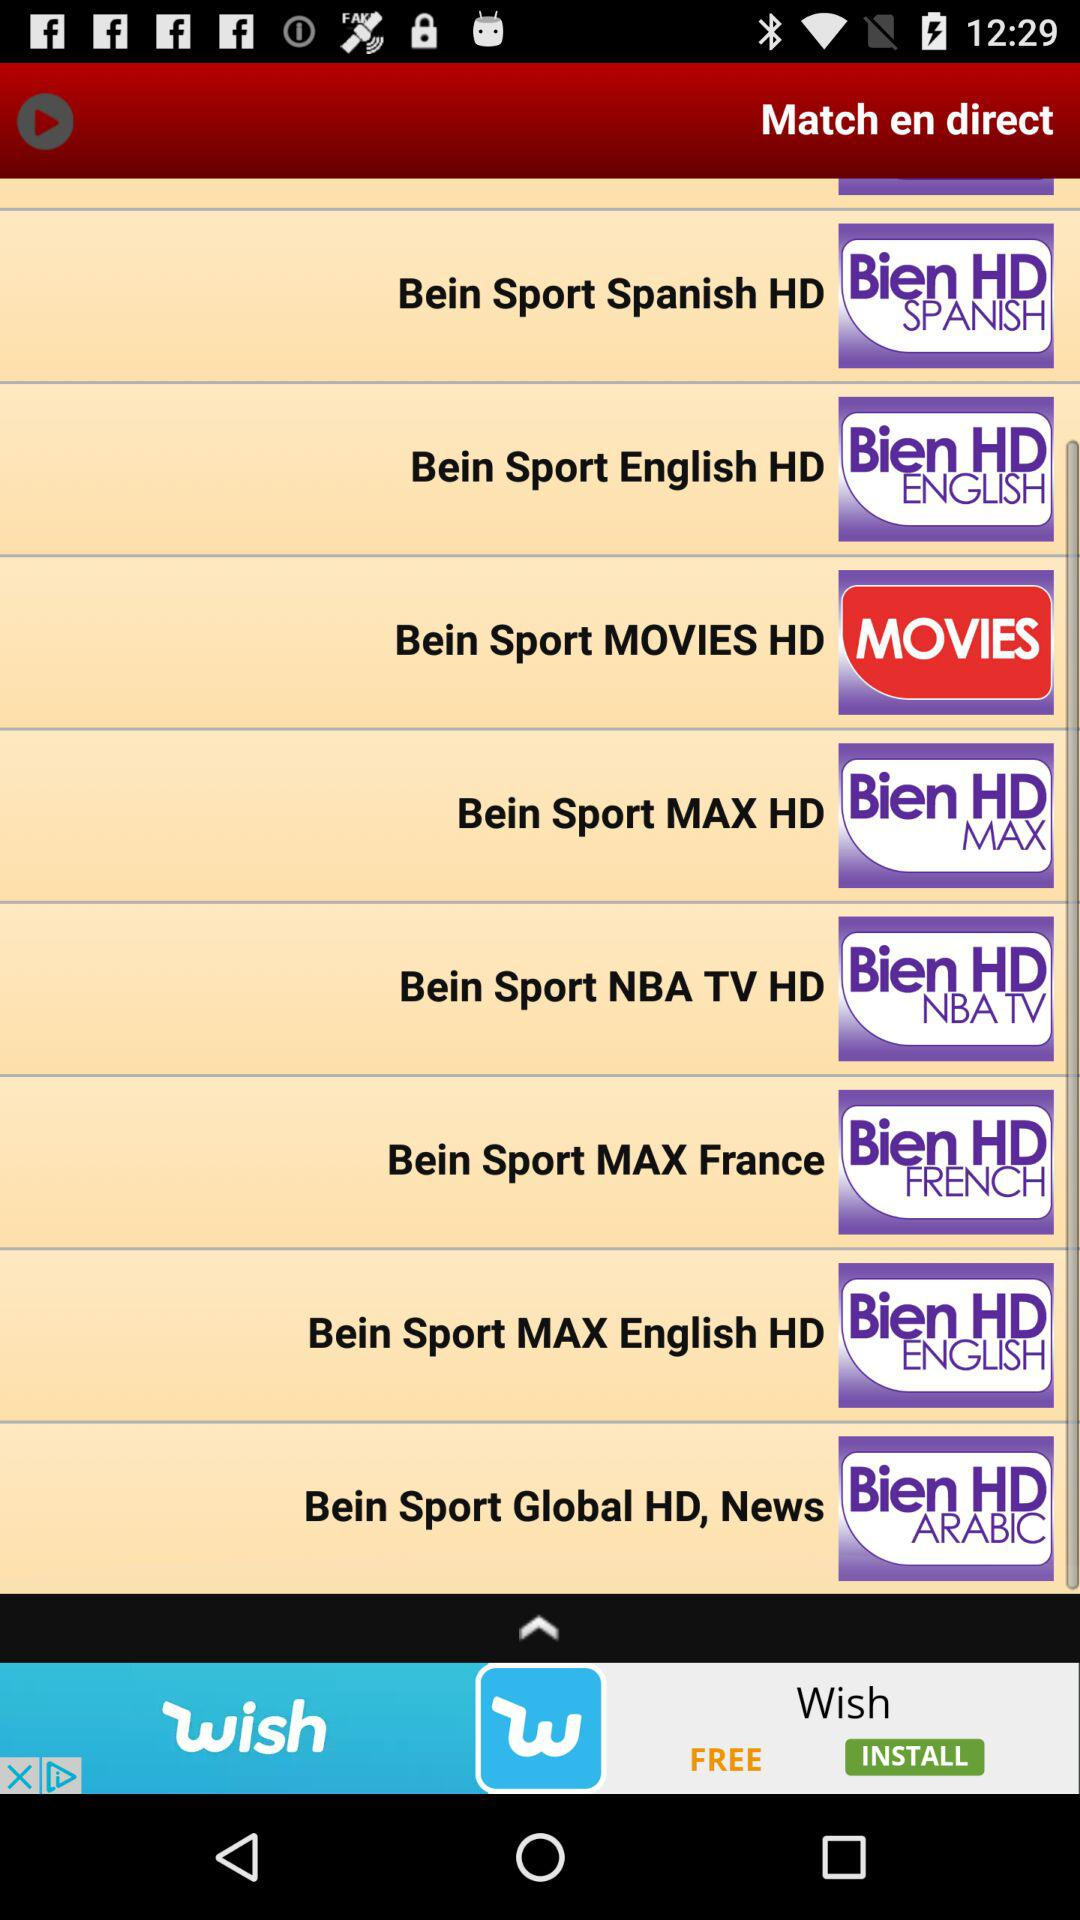How many Bein Sport channels are in the English language? Based on the image, there are two Bein Sport channels that specify English in their title: Bein Sport English HD and Bein Sport MAX English HD. These channels likely offer content primarily in English. 